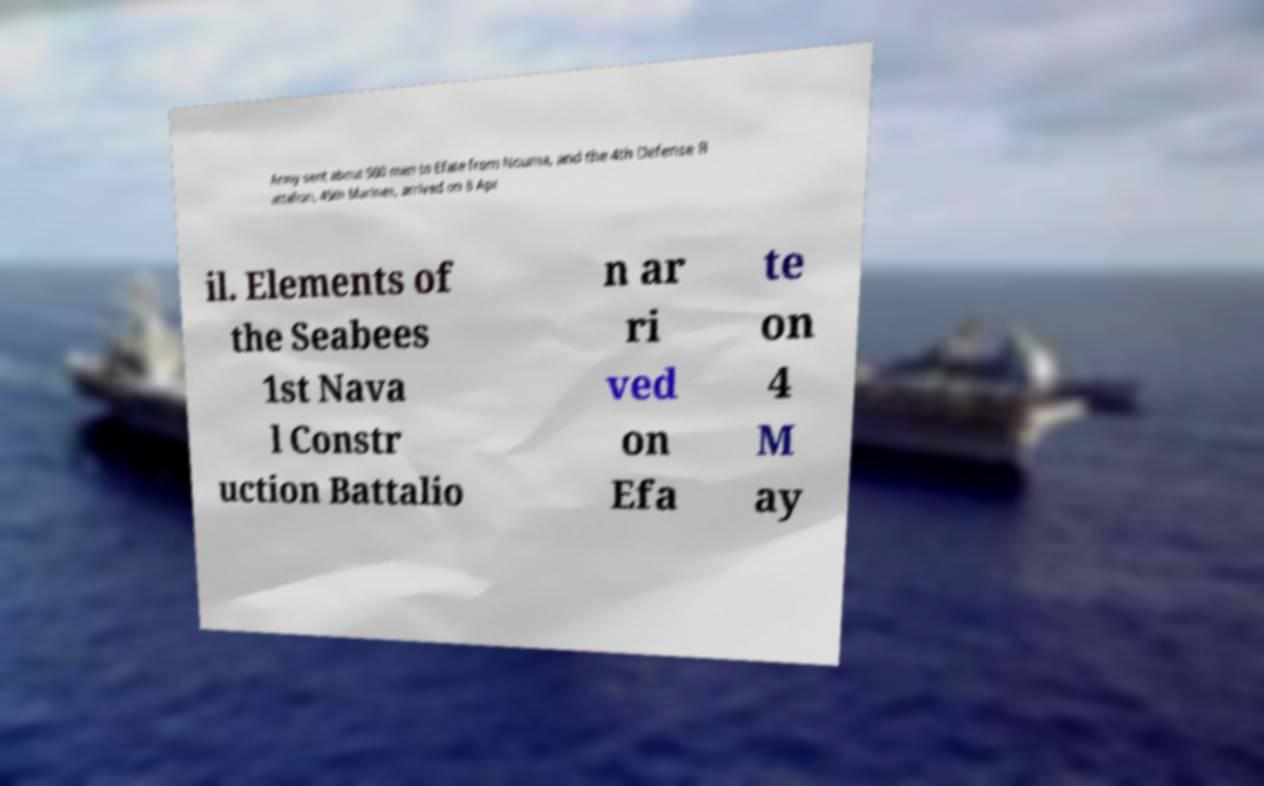For documentation purposes, I need the text within this image transcribed. Could you provide that? Army sent about 500 men to Efate from Nouma, and the 4th Defense B attalion, 45th Marines, arrived on 8 Apr il. Elements of the Seabees 1st Nava l Constr uction Battalio n ar ri ved on Efa te on 4 M ay 